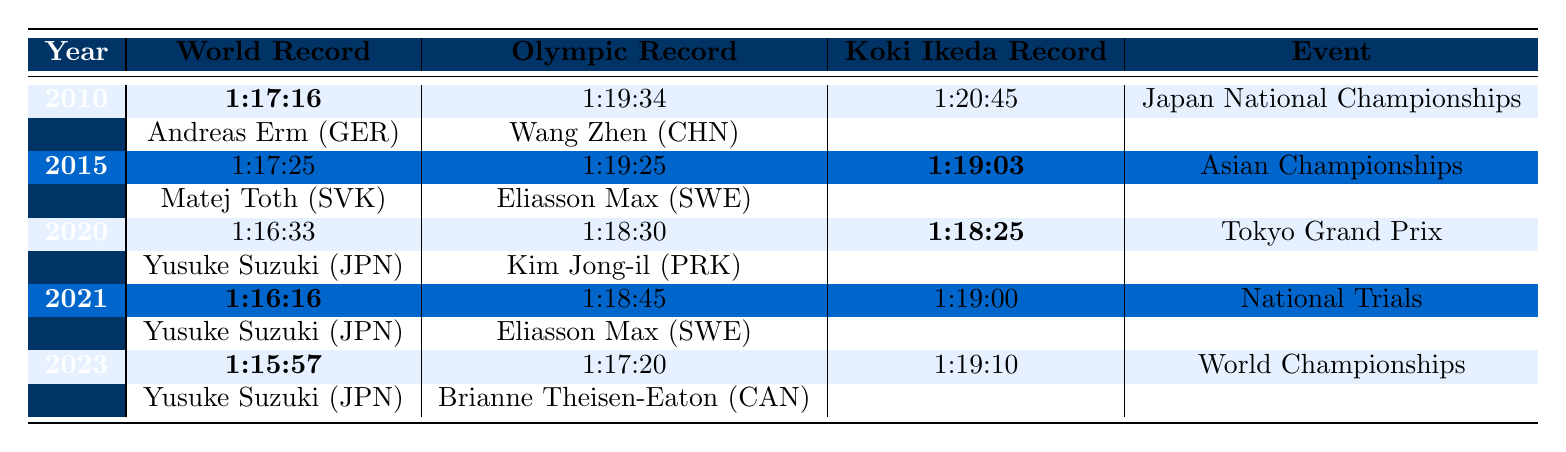What is the world record time in 2023? The table lists the world record for each year, and in 2023 it shows a time of 1:15:57.
Answer: 1:15:57 Who set the Olympic record in 2020? The Olympic record for the year 2020 is attributed to Kim Jong-il of North Korea, with a time of 1:18:30, as indicated in the table.
Answer: Kim Jong-il What is the difference between Koki Ikeda's record in 2015 and 2021? Koki Ikeda's record in 2015 is 1:19:03 and in 2021 it is 1:19:00. The difference is calculated by subtracting the earlier time from the later time: 1:19:03 - 1:19:00 = 0:03, which means he improved his time by 3 seconds.
Answer: 3 seconds Did Koki Ikeda achieve a personal best in 2023 compared to previous years? Comparing Koki Ikeda's records: 2010 (1:20:45), 2015 (1:19:03), 2020 (1:18:25), 2021 (1:19:00), and 2023 (1:19:10), his best time is 1:18:25 in 2020. Therefore, 2023 is not a personal best since 1:19:10 is worse than 1:18:25.
Answer: No What is the average world record time from 2010 to 2023? The world records are: 1:17:16 (2010), 1:17:25 (2015), 1:16:33 (2020), 1:16:16 (2021), and 1:15:57 (2023). Converting these to seconds gives 4636, 4635, 3993, 3976, and 3957 seconds respectively. The sum is 4636 + 4635 + 3993 + 3976 + 3957 = 22797 seconds. The average in seconds is 22797 / 5 = 4559.4 seconds, which converts back to 1:15:59.4.
Answer: 1:15:59 What event did Koki Ikeda participate in for his record set in 2020? The event where Koki Ikeda set his record in 2020 is labeled as the Tokyo Grand Prix in the table.
Answer: Tokyo Grand Prix Which athlete holds the world record for 2021? The world record for 2021 is held by Yusuke Suzuki from Japan with a time of 1:16:16, as indicated in the table.
Answer: Yusuke Suzuki Is there a year when Koki Ikeda's record was lower than both the world and Olympic records? In 2020, Koki Ikeda's record of 1:18:25 is lower than the Olympic record of 1:18:30 but higher than the world record of 1:16:33. Therefore, there is no year when his record is lower than both the world and Olympic records.
Answer: No What is the trend in world record times from 2010 to 2023? Observing the world records: 1:17:16 (2010), 1:17:25 (2015), 1:16:33 (2020), 1:16:16 (2021), and 1:15:57 (2023), the trend is a decline in time, indicating improvements in performance over the years.
Answer: Decline in time 